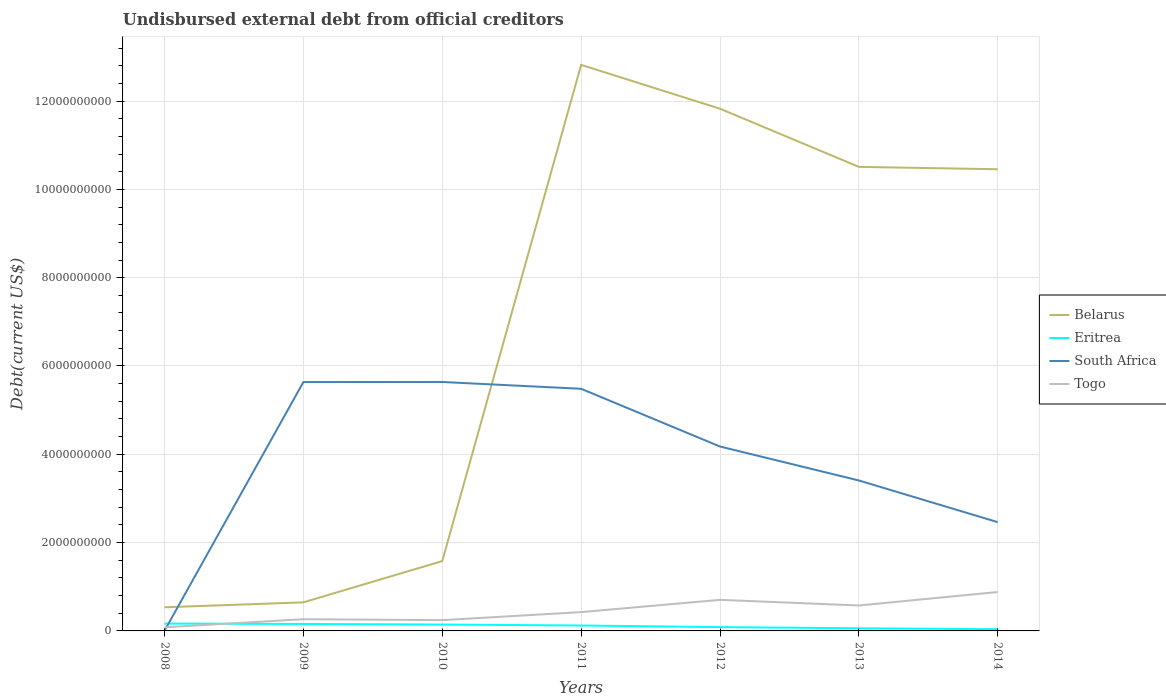Is the number of lines equal to the number of legend labels?
Your answer should be very brief. Yes. Across all years, what is the maximum total debt in South Africa?
Keep it short and to the point. 3.94e+06. In which year was the total debt in South Africa maximum?
Your answer should be very brief. 2008. What is the total total debt in Belarus in the graph?
Your answer should be compact. 2.36e+09. What is the difference between the highest and the second highest total debt in Togo?
Offer a very short reply. 7.99e+08. What is the difference between the highest and the lowest total debt in South Africa?
Make the answer very short. 4. How many lines are there?
Your answer should be compact. 4. What is the difference between two consecutive major ticks on the Y-axis?
Offer a very short reply. 2.00e+09. Are the values on the major ticks of Y-axis written in scientific E-notation?
Your response must be concise. No. Does the graph contain grids?
Give a very brief answer. Yes. Where does the legend appear in the graph?
Give a very brief answer. Center right. How are the legend labels stacked?
Offer a very short reply. Vertical. What is the title of the graph?
Your answer should be very brief. Undisbursed external debt from official creditors. What is the label or title of the X-axis?
Provide a short and direct response. Years. What is the label or title of the Y-axis?
Offer a very short reply. Debt(current US$). What is the Debt(current US$) in Belarus in 2008?
Make the answer very short. 5.35e+08. What is the Debt(current US$) of Eritrea in 2008?
Provide a succinct answer. 1.66e+08. What is the Debt(current US$) of South Africa in 2008?
Your answer should be very brief. 3.94e+06. What is the Debt(current US$) in Togo in 2008?
Provide a short and direct response. 8.21e+07. What is the Debt(current US$) in Belarus in 2009?
Your response must be concise. 6.47e+08. What is the Debt(current US$) of Eritrea in 2009?
Provide a succinct answer. 1.58e+08. What is the Debt(current US$) in South Africa in 2009?
Your answer should be compact. 5.64e+09. What is the Debt(current US$) of Togo in 2009?
Provide a succinct answer. 2.65e+08. What is the Debt(current US$) of Belarus in 2010?
Your answer should be compact. 1.58e+09. What is the Debt(current US$) in Eritrea in 2010?
Ensure brevity in your answer.  1.45e+08. What is the Debt(current US$) of South Africa in 2010?
Your answer should be compact. 5.64e+09. What is the Debt(current US$) of Togo in 2010?
Give a very brief answer. 2.44e+08. What is the Debt(current US$) in Belarus in 2011?
Make the answer very short. 1.28e+1. What is the Debt(current US$) of Eritrea in 2011?
Provide a succinct answer. 1.23e+08. What is the Debt(current US$) in South Africa in 2011?
Your answer should be very brief. 5.48e+09. What is the Debt(current US$) of Togo in 2011?
Provide a succinct answer. 4.26e+08. What is the Debt(current US$) of Belarus in 2012?
Your answer should be very brief. 1.18e+1. What is the Debt(current US$) of Eritrea in 2012?
Your answer should be very brief. 8.58e+07. What is the Debt(current US$) of South Africa in 2012?
Your response must be concise. 4.18e+09. What is the Debt(current US$) in Togo in 2012?
Give a very brief answer. 7.04e+08. What is the Debt(current US$) of Belarus in 2013?
Offer a terse response. 1.05e+1. What is the Debt(current US$) in Eritrea in 2013?
Your answer should be compact. 5.98e+07. What is the Debt(current US$) of South Africa in 2013?
Offer a very short reply. 3.41e+09. What is the Debt(current US$) in Togo in 2013?
Make the answer very short. 5.76e+08. What is the Debt(current US$) in Belarus in 2014?
Provide a short and direct response. 1.05e+1. What is the Debt(current US$) of Eritrea in 2014?
Ensure brevity in your answer.  3.90e+07. What is the Debt(current US$) in South Africa in 2014?
Your answer should be very brief. 2.46e+09. What is the Debt(current US$) of Togo in 2014?
Your response must be concise. 8.81e+08. Across all years, what is the maximum Debt(current US$) in Belarus?
Offer a very short reply. 1.28e+1. Across all years, what is the maximum Debt(current US$) in Eritrea?
Your answer should be compact. 1.66e+08. Across all years, what is the maximum Debt(current US$) in South Africa?
Provide a succinct answer. 5.64e+09. Across all years, what is the maximum Debt(current US$) in Togo?
Your answer should be compact. 8.81e+08. Across all years, what is the minimum Debt(current US$) in Belarus?
Your response must be concise. 5.35e+08. Across all years, what is the minimum Debt(current US$) in Eritrea?
Offer a terse response. 3.90e+07. Across all years, what is the minimum Debt(current US$) in South Africa?
Keep it short and to the point. 3.94e+06. Across all years, what is the minimum Debt(current US$) in Togo?
Your answer should be compact. 8.21e+07. What is the total Debt(current US$) in Belarus in the graph?
Make the answer very short. 4.84e+1. What is the total Debt(current US$) in Eritrea in the graph?
Keep it short and to the point. 7.76e+08. What is the total Debt(current US$) in South Africa in the graph?
Provide a short and direct response. 2.68e+1. What is the total Debt(current US$) of Togo in the graph?
Offer a very short reply. 3.18e+09. What is the difference between the Debt(current US$) of Belarus in 2008 and that in 2009?
Make the answer very short. -1.12e+08. What is the difference between the Debt(current US$) in Eritrea in 2008 and that in 2009?
Make the answer very short. 8.26e+06. What is the difference between the Debt(current US$) in South Africa in 2008 and that in 2009?
Keep it short and to the point. -5.63e+09. What is the difference between the Debt(current US$) of Togo in 2008 and that in 2009?
Offer a terse response. -1.83e+08. What is the difference between the Debt(current US$) of Belarus in 2008 and that in 2010?
Your response must be concise. -1.05e+09. What is the difference between the Debt(current US$) in Eritrea in 2008 and that in 2010?
Provide a succinct answer. 2.12e+07. What is the difference between the Debt(current US$) of South Africa in 2008 and that in 2010?
Your response must be concise. -5.63e+09. What is the difference between the Debt(current US$) in Togo in 2008 and that in 2010?
Provide a short and direct response. -1.62e+08. What is the difference between the Debt(current US$) of Belarus in 2008 and that in 2011?
Your response must be concise. -1.23e+1. What is the difference between the Debt(current US$) of Eritrea in 2008 and that in 2011?
Offer a very short reply. 4.30e+07. What is the difference between the Debt(current US$) in South Africa in 2008 and that in 2011?
Give a very brief answer. -5.48e+09. What is the difference between the Debt(current US$) of Togo in 2008 and that in 2011?
Ensure brevity in your answer.  -3.44e+08. What is the difference between the Debt(current US$) in Belarus in 2008 and that in 2012?
Keep it short and to the point. -1.13e+1. What is the difference between the Debt(current US$) in Eritrea in 2008 and that in 2012?
Offer a terse response. 8.01e+07. What is the difference between the Debt(current US$) in South Africa in 2008 and that in 2012?
Keep it short and to the point. -4.17e+09. What is the difference between the Debt(current US$) in Togo in 2008 and that in 2012?
Your answer should be very brief. -6.22e+08. What is the difference between the Debt(current US$) of Belarus in 2008 and that in 2013?
Keep it short and to the point. -9.97e+09. What is the difference between the Debt(current US$) of Eritrea in 2008 and that in 2013?
Give a very brief answer. 1.06e+08. What is the difference between the Debt(current US$) of South Africa in 2008 and that in 2013?
Keep it short and to the point. -3.40e+09. What is the difference between the Debt(current US$) in Togo in 2008 and that in 2013?
Your answer should be compact. -4.94e+08. What is the difference between the Debt(current US$) of Belarus in 2008 and that in 2014?
Provide a short and direct response. -9.92e+09. What is the difference between the Debt(current US$) in Eritrea in 2008 and that in 2014?
Your response must be concise. 1.27e+08. What is the difference between the Debt(current US$) in South Africa in 2008 and that in 2014?
Your answer should be compact. -2.46e+09. What is the difference between the Debt(current US$) in Togo in 2008 and that in 2014?
Your answer should be compact. -7.99e+08. What is the difference between the Debt(current US$) in Belarus in 2009 and that in 2010?
Provide a succinct answer. -9.34e+08. What is the difference between the Debt(current US$) of Eritrea in 2009 and that in 2010?
Give a very brief answer. 1.29e+07. What is the difference between the Debt(current US$) of South Africa in 2009 and that in 2010?
Provide a succinct answer. -1.40e+06. What is the difference between the Debt(current US$) of Togo in 2009 and that in 2010?
Provide a short and direct response. 2.11e+07. What is the difference between the Debt(current US$) of Belarus in 2009 and that in 2011?
Your answer should be very brief. -1.22e+1. What is the difference between the Debt(current US$) in Eritrea in 2009 and that in 2011?
Make the answer very short. 3.47e+07. What is the difference between the Debt(current US$) in South Africa in 2009 and that in 2011?
Keep it short and to the point. 1.53e+08. What is the difference between the Debt(current US$) in Togo in 2009 and that in 2011?
Your answer should be compact. -1.61e+08. What is the difference between the Debt(current US$) of Belarus in 2009 and that in 2012?
Ensure brevity in your answer.  -1.12e+1. What is the difference between the Debt(current US$) of Eritrea in 2009 and that in 2012?
Offer a very short reply. 7.18e+07. What is the difference between the Debt(current US$) in South Africa in 2009 and that in 2012?
Keep it short and to the point. 1.46e+09. What is the difference between the Debt(current US$) of Togo in 2009 and that in 2012?
Ensure brevity in your answer.  -4.38e+08. What is the difference between the Debt(current US$) of Belarus in 2009 and that in 2013?
Your answer should be compact. -9.86e+09. What is the difference between the Debt(current US$) of Eritrea in 2009 and that in 2013?
Your response must be concise. 9.78e+07. What is the difference between the Debt(current US$) in South Africa in 2009 and that in 2013?
Provide a short and direct response. 2.23e+09. What is the difference between the Debt(current US$) in Togo in 2009 and that in 2013?
Make the answer very short. -3.11e+08. What is the difference between the Debt(current US$) in Belarus in 2009 and that in 2014?
Offer a very short reply. -9.81e+09. What is the difference between the Debt(current US$) in Eritrea in 2009 and that in 2014?
Your answer should be very brief. 1.19e+08. What is the difference between the Debt(current US$) in South Africa in 2009 and that in 2014?
Offer a very short reply. 3.17e+09. What is the difference between the Debt(current US$) in Togo in 2009 and that in 2014?
Provide a short and direct response. -6.16e+08. What is the difference between the Debt(current US$) of Belarus in 2010 and that in 2011?
Make the answer very short. -1.12e+1. What is the difference between the Debt(current US$) in Eritrea in 2010 and that in 2011?
Provide a succinct answer. 2.18e+07. What is the difference between the Debt(current US$) in South Africa in 2010 and that in 2011?
Your response must be concise. 1.54e+08. What is the difference between the Debt(current US$) of Togo in 2010 and that in 2011?
Make the answer very short. -1.82e+08. What is the difference between the Debt(current US$) in Belarus in 2010 and that in 2012?
Give a very brief answer. -1.02e+1. What is the difference between the Debt(current US$) of Eritrea in 2010 and that in 2012?
Give a very brief answer. 5.89e+07. What is the difference between the Debt(current US$) of South Africa in 2010 and that in 2012?
Make the answer very short. 1.46e+09. What is the difference between the Debt(current US$) of Togo in 2010 and that in 2012?
Offer a very short reply. -4.60e+08. What is the difference between the Debt(current US$) of Belarus in 2010 and that in 2013?
Give a very brief answer. -8.93e+09. What is the difference between the Debt(current US$) in Eritrea in 2010 and that in 2013?
Provide a succinct answer. 8.49e+07. What is the difference between the Debt(current US$) of South Africa in 2010 and that in 2013?
Offer a terse response. 2.23e+09. What is the difference between the Debt(current US$) of Togo in 2010 and that in 2013?
Ensure brevity in your answer.  -3.32e+08. What is the difference between the Debt(current US$) in Belarus in 2010 and that in 2014?
Keep it short and to the point. -8.87e+09. What is the difference between the Debt(current US$) in Eritrea in 2010 and that in 2014?
Provide a short and direct response. 1.06e+08. What is the difference between the Debt(current US$) of South Africa in 2010 and that in 2014?
Keep it short and to the point. 3.17e+09. What is the difference between the Debt(current US$) of Togo in 2010 and that in 2014?
Provide a succinct answer. -6.37e+08. What is the difference between the Debt(current US$) of Belarus in 2011 and that in 2012?
Your response must be concise. 9.93e+08. What is the difference between the Debt(current US$) in Eritrea in 2011 and that in 2012?
Offer a terse response. 3.71e+07. What is the difference between the Debt(current US$) of South Africa in 2011 and that in 2012?
Ensure brevity in your answer.  1.31e+09. What is the difference between the Debt(current US$) of Togo in 2011 and that in 2012?
Offer a terse response. -2.78e+08. What is the difference between the Debt(current US$) of Belarus in 2011 and that in 2013?
Ensure brevity in your answer.  2.31e+09. What is the difference between the Debt(current US$) of Eritrea in 2011 and that in 2013?
Keep it short and to the point. 6.31e+07. What is the difference between the Debt(current US$) in South Africa in 2011 and that in 2013?
Ensure brevity in your answer.  2.08e+09. What is the difference between the Debt(current US$) of Togo in 2011 and that in 2013?
Your response must be concise. -1.50e+08. What is the difference between the Debt(current US$) in Belarus in 2011 and that in 2014?
Make the answer very short. 2.36e+09. What is the difference between the Debt(current US$) of Eritrea in 2011 and that in 2014?
Make the answer very short. 8.38e+07. What is the difference between the Debt(current US$) of South Africa in 2011 and that in 2014?
Your response must be concise. 3.02e+09. What is the difference between the Debt(current US$) in Togo in 2011 and that in 2014?
Provide a short and direct response. -4.55e+08. What is the difference between the Debt(current US$) of Belarus in 2012 and that in 2013?
Provide a short and direct response. 1.32e+09. What is the difference between the Debt(current US$) of Eritrea in 2012 and that in 2013?
Make the answer very short. 2.60e+07. What is the difference between the Debt(current US$) of South Africa in 2012 and that in 2013?
Give a very brief answer. 7.69e+08. What is the difference between the Debt(current US$) of Togo in 2012 and that in 2013?
Provide a succinct answer. 1.28e+08. What is the difference between the Debt(current US$) of Belarus in 2012 and that in 2014?
Ensure brevity in your answer.  1.37e+09. What is the difference between the Debt(current US$) in Eritrea in 2012 and that in 2014?
Give a very brief answer. 4.68e+07. What is the difference between the Debt(current US$) in South Africa in 2012 and that in 2014?
Give a very brief answer. 1.71e+09. What is the difference between the Debt(current US$) in Togo in 2012 and that in 2014?
Offer a terse response. -1.77e+08. What is the difference between the Debt(current US$) of Belarus in 2013 and that in 2014?
Make the answer very short. 5.39e+07. What is the difference between the Debt(current US$) of Eritrea in 2013 and that in 2014?
Your answer should be very brief. 2.08e+07. What is the difference between the Debt(current US$) in South Africa in 2013 and that in 2014?
Offer a very short reply. 9.44e+08. What is the difference between the Debt(current US$) of Togo in 2013 and that in 2014?
Offer a terse response. -3.05e+08. What is the difference between the Debt(current US$) in Belarus in 2008 and the Debt(current US$) in Eritrea in 2009?
Your response must be concise. 3.78e+08. What is the difference between the Debt(current US$) of Belarus in 2008 and the Debt(current US$) of South Africa in 2009?
Give a very brief answer. -5.10e+09. What is the difference between the Debt(current US$) in Belarus in 2008 and the Debt(current US$) in Togo in 2009?
Your answer should be very brief. 2.70e+08. What is the difference between the Debt(current US$) in Eritrea in 2008 and the Debt(current US$) in South Africa in 2009?
Your response must be concise. -5.47e+09. What is the difference between the Debt(current US$) in Eritrea in 2008 and the Debt(current US$) in Togo in 2009?
Give a very brief answer. -9.93e+07. What is the difference between the Debt(current US$) of South Africa in 2008 and the Debt(current US$) of Togo in 2009?
Your response must be concise. -2.61e+08. What is the difference between the Debt(current US$) in Belarus in 2008 and the Debt(current US$) in Eritrea in 2010?
Your answer should be compact. 3.91e+08. What is the difference between the Debt(current US$) in Belarus in 2008 and the Debt(current US$) in South Africa in 2010?
Offer a terse response. -5.10e+09. What is the difference between the Debt(current US$) in Belarus in 2008 and the Debt(current US$) in Togo in 2010?
Give a very brief answer. 2.91e+08. What is the difference between the Debt(current US$) in Eritrea in 2008 and the Debt(current US$) in South Africa in 2010?
Your answer should be very brief. -5.47e+09. What is the difference between the Debt(current US$) of Eritrea in 2008 and the Debt(current US$) of Togo in 2010?
Offer a very short reply. -7.82e+07. What is the difference between the Debt(current US$) in South Africa in 2008 and the Debt(current US$) in Togo in 2010?
Provide a short and direct response. -2.40e+08. What is the difference between the Debt(current US$) of Belarus in 2008 and the Debt(current US$) of Eritrea in 2011?
Make the answer very short. 4.12e+08. What is the difference between the Debt(current US$) of Belarus in 2008 and the Debt(current US$) of South Africa in 2011?
Your answer should be compact. -4.95e+09. What is the difference between the Debt(current US$) in Belarus in 2008 and the Debt(current US$) in Togo in 2011?
Your response must be concise. 1.09e+08. What is the difference between the Debt(current US$) in Eritrea in 2008 and the Debt(current US$) in South Africa in 2011?
Offer a very short reply. -5.32e+09. What is the difference between the Debt(current US$) in Eritrea in 2008 and the Debt(current US$) in Togo in 2011?
Make the answer very short. -2.60e+08. What is the difference between the Debt(current US$) of South Africa in 2008 and the Debt(current US$) of Togo in 2011?
Provide a short and direct response. -4.22e+08. What is the difference between the Debt(current US$) in Belarus in 2008 and the Debt(current US$) in Eritrea in 2012?
Your answer should be very brief. 4.50e+08. What is the difference between the Debt(current US$) in Belarus in 2008 and the Debt(current US$) in South Africa in 2012?
Offer a very short reply. -3.64e+09. What is the difference between the Debt(current US$) of Belarus in 2008 and the Debt(current US$) of Togo in 2012?
Give a very brief answer. -1.68e+08. What is the difference between the Debt(current US$) in Eritrea in 2008 and the Debt(current US$) in South Africa in 2012?
Provide a short and direct response. -4.01e+09. What is the difference between the Debt(current US$) in Eritrea in 2008 and the Debt(current US$) in Togo in 2012?
Offer a terse response. -5.38e+08. What is the difference between the Debt(current US$) of South Africa in 2008 and the Debt(current US$) of Togo in 2012?
Provide a succinct answer. -7.00e+08. What is the difference between the Debt(current US$) in Belarus in 2008 and the Debt(current US$) in Eritrea in 2013?
Make the answer very short. 4.75e+08. What is the difference between the Debt(current US$) in Belarus in 2008 and the Debt(current US$) in South Africa in 2013?
Provide a succinct answer. -2.87e+09. What is the difference between the Debt(current US$) of Belarus in 2008 and the Debt(current US$) of Togo in 2013?
Keep it short and to the point. -4.06e+07. What is the difference between the Debt(current US$) of Eritrea in 2008 and the Debt(current US$) of South Africa in 2013?
Ensure brevity in your answer.  -3.24e+09. What is the difference between the Debt(current US$) of Eritrea in 2008 and the Debt(current US$) of Togo in 2013?
Give a very brief answer. -4.10e+08. What is the difference between the Debt(current US$) in South Africa in 2008 and the Debt(current US$) in Togo in 2013?
Make the answer very short. -5.72e+08. What is the difference between the Debt(current US$) of Belarus in 2008 and the Debt(current US$) of Eritrea in 2014?
Your answer should be very brief. 4.96e+08. What is the difference between the Debt(current US$) of Belarus in 2008 and the Debt(current US$) of South Africa in 2014?
Keep it short and to the point. -1.93e+09. What is the difference between the Debt(current US$) of Belarus in 2008 and the Debt(current US$) of Togo in 2014?
Provide a succinct answer. -3.46e+08. What is the difference between the Debt(current US$) in Eritrea in 2008 and the Debt(current US$) in South Africa in 2014?
Make the answer very short. -2.30e+09. What is the difference between the Debt(current US$) in Eritrea in 2008 and the Debt(current US$) in Togo in 2014?
Provide a short and direct response. -7.15e+08. What is the difference between the Debt(current US$) in South Africa in 2008 and the Debt(current US$) in Togo in 2014?
Ensure brevity in your answer.  -8.77e+08. What is the difference between the Debt(current US$) in Belarus in 2009 and the Debt(current US$) in Eritrea in 2010?
Your response must be concise. 5.03e+08. What is the difference between the Debt(current US$) in Belarus in 2009 and the Debt(current US$) in South Africa in 2010?
Ensure brevity in your answer.  -4.99e+09. What is the difference between the Debt(current US$) in Belarus in 2009 and the Debt(current US$) in Togo in 2010?
Your answer should be compact. 4.03e+08. What is the difference between the Debt(current US$) in Eritrea in 2009 and the Debt(current US$) in South Africa in 2010?
Your answer should be compact. -5.48e+09. What is the difference between the Debt(current US$) of Eritrea in 2009 and the Debt(current US$) of Togo in 2010?
Give a very brief answer. -8.65e+07. What is the difference between the Debt(current US$) of South Africa in 2009 and the Debt(current US$) of Togo in 2010?
Ensure brevity in your answer.  5.39e+09. What is the difference between the Debt(current US$) in Belarus in 2009 and the Debt(current US$) in Eritrea in 2011?
Give a very brief answer. 5.24e+08. What is the difference between the Debt(current US$) in Belarus in 2009 and the Debt(current US$) in South Africa in 2011?
Provide a short and direct response. -4.84e+09. What is the difference between the Debt(current US$) of Belarus in 2009 and the Debt(current US$) of Togo in 2011?
Keep it short and to the point. 2.21e+08. What is the difference between the Debt(current US$) in Eritrea in 2009 and the Debt(current US$) in South Africa in 2011?
Ensure brevity in your answer.  -5.33e+09. What is the difference between the Debt(current US$) in Eritrea in 2009 and the Debt(current US$) in Togo in 2011?
Keep it short and to the point. -2.68e+08. What is the difference between the Debt(current US$) in South Africa in 2009 and the Debt(current US$) in Togo in 2011?
Provide a succinct answer. 5.21e+09. What is the difference between the Debt(current US$) of Belarus in 2009 and the Debt(current US$) of Eritrea in 2012?
Provide a succinct answer. 5.61e+08. What is the difference between the Debt(current US$) of Belarus in 2009 and the Debt(current US$) of South Africa in 2012?
Offer a terse response. -3.53e+09. What is the difference between the Debt(current US$) in Belarus in 2009 and the Debt(current US$) in Togo in 2012?
Your response must be concise. -5.64e+07. What is the difference between the Debt(current US$) in Eritrea in 2009 and the Debt(current US$) in South Africa in 2012?
Your response must be concise. -4.02e+09. What is the difference between the Debt(current US$) of Eritrea in 2009 and the Debt(current US$) of Togo in 2012?
Provide a short and direct response. -5.46e+08. What is the difference between the Debt(current US$) in South Africa in 2009 and the Debt(current US$) in Togo in 2012?
Offer a very short reply. 4.93e+09. What is the difference between the Debt(current US$) in Belarus in 2009 and the Debt(current US$) in Eritrea in 2013?
Provide a short and direct response. 5.87e+08. What is the difference between the Debt(current US$) in Belarus in 2009 and the Debt(current US$) in South Africa in 2013?
Ensure brevity in your answer.  -2.76e+09. What is the difference between the Debt(current US$) of Belarus in 2009 and the Debt(current US$) of Togo in 2013?
Provide a short and direct response. 7.14e+07. What is the difference between the Debt(current US$) of Eritrea in 2009 and the Debt(current US$) of South Africa in 2013?
Give a very brief answer. -3.25e+09. What is the difference between the Debt(current US$) of Eritrea in 2009 and the Debt(current US$) of Togo in 2013?
Keep it short and to the point. -4.18e+08. What is the difference between the Debt(current US$) of South Africa in 2009 and the Debt(current US$) of Togo in 2013?
Offer a terse response. 5.06e+09. What is the difference between the Debt(current US$) of Belarus in 2009 and the Debt(current US$) of Eritrea in 2014?
Offer a very short reply. 6.08e+08. What is the difference between the Debt(current US$) of Belarus in 2009 and the Debt(current US$) of South Africa in 2014?
Give a very brief answer. -1.82e+09. What is the difference between the Debt(current US$) of Belarus in 2009 and the Debt(current US$) of Togo in 2014?
Your answer should be compact. -2.34e+08. What is the difference between the Debt(current US$) in Eritrea in 2009 and the Debt(current US$) in South Africa in 2014?
Your answer should be very brief. -2.31e+09. What is the difference between the Debt(current US$) in Eritrea in 2009 and the Debt(current US$) in Togo in 2014?
Make the answer very short. -7.24e+08. What is the difference between the Debt(current US$) of South Africa in 2009 and the Debt(current US$) of Togo in 2014?
Give a very brief answer. 4.76e+09. What is the difference between the Debt(current US$) in Belarus in 2010 and the Debt(current US$) in Eritrea in 2011?
Keep it short and to the point. 1.46e+09. What is the difference between the Debt(current US$) in Belarus in 2010 and the Debt(current US$) in South Africa in 2011?
Provide a succinct answer. -3.90e+09. What is the difference between the Debt(current US$) in Belarus in 2010 and the Debt(current US$) in Togo in 2011?
Offer a terse response. 1.16e+09. What is the difference between the Debt(current US$) in Eritrea in 2010 and the Debt(current US$) in South Africa in 2011?
Ensure brevity in your answer.  -5.34e+09. What is the difference between the Debt(current US$) in Eritrea in 2010 and the Debt(current US$) in Togo in 2011?
Offer a very short reply. -2.81e+08. What is the difference between the Debt(current US$) in South Africa in 2010 and the Debt(current US$) in Togo in 2011?
Provide a short and direct response. 5.21e+09. What is the difference between the Debt(current US$) of Belarus in 2010 and the Debt(current US$) of Eritrea in 2012?
Your answer should be compact. 1.50e+09. What is the difference between the Debt(current US$) of Belarus in 2010 and the Debt(current US$) of South Africa in 2012?
Offer a very short reply. -2.59e+09. What is the difference between the Debt(current US$) of Belarus in 2010 and the Debt(current US$) of Togo in 2012?
Provide a short and direct response. 8.78e+08. What is the difference between the Debt(current US$) of Eritrea in 2010 and the Debt(current US$) of South Africa in 2012?
Your response must be concise. -4.03e+09. What is the difference between the Debt(current US$) of Eritrea in 2010 and the Debt(current US$) of Togo in 2012?
Offer a terse response. -5.59e+08. What is the difference between the Debt(current US$) in South Africa in 2010 and the Debt(current US$) in Togo in 2012?
Provide a short and direct response. 4.93e+09. What is the difference between the Debt(current US$) of Belarus in 2010 and the Debt(current US$) of Eritrea in 2013?
Provide a succinct answer. 1.52e+09. What is the difference between the Debt(current US$) of Belarus in 2010 and the Debt(current US$) of South Africa in 2013?
Make the answer very short. -1.83e+09. What is the difference between the Debt(current US$) of Belarus in 2010 and the Debt(current US$) of Togo in 2013?
Provide a short and direct response. 1.01e+09. What is the difference between the Debt(current US$) of Eritrea in 2010 and the Debt(current US$) of South Africa in 2013?
Ensure brevity in your answer.  -3.26e+09. What is the difference between the Debt(current US$) of Eritrea in 2010 and the Debt(current US$) of Togo in 2013?
Keep it short and to the point. -4.31e+08. What is the difference between the Debt(current US$) of South Africa in 2010 and the Debt(current US$) of Togo in 2013?
Provide a succinct answer. 5.06e+09. What is the difference between the Debt(current US$) of Belarus in 2010 and the Debt(current US$) of Eritrea in 2014?
Offer a very short reply. 1.54e+09. What is the difference between the Debt(current US$) of Belarus in 2010 and the Debt(current US$) of South Africa in 2014?
Make the answer very short. -8.82e+08. What is the difference between the Debt(current US$) of Belarus in 2010 and the Debt(current US$) of Togo in 2014?
Give a very brief answer. 7.00e+08. What is the difference between the Debt(current US$) in Eritrea in 2010 and the Debt(current US$) in South Africa in 2014?
Provide a succinct answer. -2.32e+09. What is the difference between the Debt(current US$) of Eritrea in 2010 and the Debt(current US$) of Togo in 2014?
Make the answer very short. -7.36e+08. What is the difference between the Debt(current US$) of South Africa in 2010 and the Debt(current US$) of Togo in 2014?
Provide a short and direct response. 4.76e+09. What is the difference between the Debt(current US$) of Belarus in 2011 and the Debt(current US$) of Eritrea in 2012?
Your response must be concise. 1.27e+1. What is the difference between the Debt(current US$) of Belarus in 2011 and the Debt(current US$) of South Africa in 2012?
Your answer should be compact. 8.64e+09. What is the difference between the Debt(current US$) in Belarus in 2011 and the Debt(current US$) in Togo in 2012?
Offer a very short reply. 1.21e+1. What is the difference between the Debt(current US$) of Eritrea in 2011 and the Debt(current US$) of South Africa in 2012?
Keep it short and to the point. -4.05e+09. What is the difference between the Debt(current US$) in Eritrea in 2011 and the Debt(current US$) in Togo in 2012?
Give a very brief answer. -5.81e+08. What is the difference between the Debt(current US$) of South Africa in 2011 and the Debt(current US$) of Togo in 2012?
Provide a short and direct response. 4.78e+09. What is the difference between the Debt(current US$) in Belarus in 2011 and the Debt(current US$) in Eritrea in 2013?
Offer a terse response. 1.28e+1. What is the difference between the Debt(current US$) in Belarus in 2011 and the Debt(current US$) in South Africa in 2013?
Provide a succinct answer. 9.41e+09. What is the difference between the Debt(current US$) in Belarus in 2011 and the Debt(current US$) in Togo in 2013?
Your answer should be very brief. 1.22e+1. What is the difference between the Debt(current US$) in Eritrea in 2011 and the Debt(current US$) in South Africa in 2013?
Your answer should be compact. -3.28e+09. What is the difference between the Debt(current US$) in Eritrea in 2011 and the Debt(current US$) in Togo in 2013?
Keep it short and to the point. -4.53e+08. What is the difference between the Debt(current US$) in South Africa in 2011 and the Debt(current US$) in Togo in 2013?
Provide a short and direct response. 4.91e+09. What is the difference between the Debt(current US$) of Belarus in 2011 and the Debt(current US$) of Eritrea in 2014?
Offer a terse response. 1.28e+1. What is the difference between the Debt(current US$) in Belarus in 2011 and the Debt(current US$) in South Africa in 2014?
Keep it short and to the point. 1.04e+1. What is the difference between the Debt(current US$) in Belarus in 2011 and the Debt(current US$) in Togo in 2014?
Keep it short and to the point. 1.19e+1. What is the difference between the Debt(current US$) in Eritrea in 2011 and the Debt(current US$) in South Africa in 2014?
Provide a short and direct response. -2.34e+09. What is the difference between the Debt(current US$) in Eritrea in 2011 and the Debt(current US$) in Togo in 2014?
Your response must be concise. -7.58e+08. What is the difference between the Debt(current US$) of South Africa in 2011 and the Debt(current US$) of Togo in 2014?
Your response must be concise. 4.60e+09. What is the difference between the Debt(current US$) in Belarus in 2012 and the Debt(current US$) in Eritrea in 2013?
Offer a terse response. 1.18e+1. What is the difference between the Debt(current US$) of Belarus in 2012 and the Debt(current US$) of South Africa in 2013?
Make the answer very short. 8.42e+09. What is the difference between the Debt(current US$) in Belarus in 2012 and the Debt(current US$) in Togo in 2013?
Keep it short and to the point. 1.13e+1. What is the difference between the Debt(current US$) of Eritrea in 2012 and the Debt(current US$) of South Africa in 2013?
Keep it short and to the point. -3.32e+09. What is the difference between the Debt(current US$) in Eritrea in 2012 and the Debt(current US$) in Togo in 2013?
Your response must be concise. -4.90e+08. What is the difference between the Debt(current US$) of South Africa in 2012 and the Debt(current US$) of Togo in 2013?
Provide a short and direct response. 3.60e+09. What is the difference between the Debt(current US$) of Belarus in 2012 and the Debt(current US$) of Eritrea in 2014?
Keep it short and to the point. 1.18e+1. What is the difference between the Debt(current US$) in Belarus in 2012 and the Debt(current US$) in South Africa in 2014?
Offer a terse response. 9.36e+09. What is the difference between the Debt(current US$) of Belarus in 2012 and the Debt(current US$) of Togo in 2014?
Your answer should be very brief. 1.09e+1. What is the difference between the Debt(current US$) of Eritrea in 2012 and the Debt(current US$) of South Africa in 2014?
Provide a succinct answer. -2.38e+09. What is the difference between the Debt(current US$) in Eritrea in 2012 and the Debt(current US$) in Togo in 2014?
Give a very brief answer. -7.95e+08. What is the difference between the Debt(current US$) in South Africa in 2012 and the Debt(current US$) in Togo in 2014?
Provide a short and direct response. 3.29e+09. What is the difference between the Debt(current US$) in Belarus in 2013 and the Debt(current US$) in Eritrea in 2014?
Give a very brief answer. 1.05e+1. What is the difference between the Debt(current US$) of Belarus in 2013 and the Debt(current US$) of South Africa in 2014?
Offer a terse response. 8.05e+09. What is the difference between the Debt(current US$) in Belarus in 2013 and the Debt(current US$) in Togo in 2014?
Make the answer very short. 9.63e+09. What is the difference between the Debt(current US$) in Eritrea in 2013 and the Debt(current US$) in South Africa in 2014?
Your answer should be very brief. -2.40e+09. What is the difference between the Debt(current US$) of Eritrea in 2013 and the Debt(current US$) of Togo in 2014?
Offer a very short reply. -8.21e+08. What is the difference between the Debt(current US$) of South Africa in 2013 and the Debt(current US$) of Togo in 2014?
Offer a terse response. 2.53e+09. What is the average Debt(current US$) of Belarus per year?
Provide a succinct answer. 6.91e+09. What is the average Debt(current US$) in Eritrea per year?
Ensure brevity in your answer.  1.11e+08. What is the average Debt(current US$) in South Africa per year?
Ensure brevity in your answer.  3.83e+09. What is the average Debt(current US$) of Togo per year?
Keep it short and to the point. 4.54e+08. In the year 2008, what is the difference between the Debt(current US$) in Belarus and Debt(current US$) in Eritrea?
Your answer should be compact. 3.69e+08. In the year 2008, what is the difference between the Debt(current US$) of Belarus and Debt(current US$) of South Africa?
Provide a short and direct response. 5.31e+08. In the year 2008, what is the difference between the Debt(current US$) of Belarus and Debt(current US$) of Togo?
Your response must be concise. 4.53e+08. In the year 2008, what is the difference between the Debt(current US$) of Eritrea and Debt(current US$) of South Africa?
Provide a succinct answer. 1.62e+08. In the year 2008, what is the difference between the Debt(current US$) in Eritrea and Debt(current US$) in Togo?
Offer a very short reply. 8.37e+07. In the year 2008, what is the difference between the Debt(current US$) of South Africa and Debt(current US$) of Togo?
Make the answer very short. -7.82e+07. In the year 2009, what is the difference between the Debt(current US$) in Belarus and Debt(current US$) in Eritrea?
Keep it short and to the point. 4.90e+08. In the year 2009, what is the difference between the Debt(current US$) of Belarus and Debt(current US$) of South Africa?
Provide a short and direct response. -4.99e+09. In the year 2009, what is the difference between the Debt(current US$) in Belarus and Debt(current US$) in Togo?
Give a very brief answer. 3.82e+08. In the year 2009, what is the difference between the Debt(current US$) of Eritrea and Debt(current US$) of South Africa?
Offer a terse response. -5.48e+09. In the year 2009, what is the difference between the Debt(current US$) in Eritrea and Debt(current US$) in Togo?
Ensure brevity in your answer.  -1.08e+08. In the year 2009, what is the difference between the Debt(current US$) in South Africa and Debt(current US$) in Togo?
Offer a terse response. 5.37e+09. In the year 2010, what is the difference between the Debt(current US$) of Belarus and Debt(current US$) of Eritrea?
Keep it short and to the point. 1.44e+09. In the year 2010, what is the difference between the Debt(current US$) in Belarus and Debt(current US$) in South Africa?
Offer a very short reply. -4.06e+09. In the year 2010, what is the difference between the Debt(current US$) in Belarus and Debt(current US$) in Togo?
Provide a short and direct response. 1.34e+09. In the year 2010, what is the difference between the Debt(current US$) in Eritrea and Debt(current US$) in South Africa?
Ensure brevity in your answer.  -5.49e+09. In the year 2010, what is the difference between the Debt(current US$) of Eritrea and Debt(current US$) of Togo?
Your answer should be compact. -9.94e+07. In the year 2010, what is the difference between the Debt(current US$) of South Africa and Debt(current US$) of Togo?
Provide a short and direct response. 5.39e+09. In the year 2011, what is the difference between the Debt(current US$) in Belarus and Debt(current US$) in Eritrea?
Offer a very short reply. 1.27e+1. In the year 2011, what is the difference between the Debt(current US$) in Belarus and Debt(current US$) in South Africa?
Offer a very short reply. 7.34e+09. In the year 2011, what is the difference between the Debt(current US$) in Belarus and Debt(current US$) in Togo?
Your answer should be compact. 1.24e+1. In the year 2011, what is the difference between the Debt(current US$) of Eritrea and Debt(current US$) of South Africa?
Make the answer very short. -5.36e+09. In the year 2011, what is the difference between the Debt(current US$) in Eritrea and Debt(current US$) in Togo?
Your answer should be very brief. -3.03e+08. In the year 2011, what is the difference between the Debt(current US$) in South Africa and Debt(current US$) in Togo?
Offer a very short reply. 5.06e+09. In the year 2012, what is the difference between the Debt(current US$) in Belarus and Debt(current US$) in Eritrea?
Provide a short and direct response. 1.17e+1. In the year 2012, what is the difference between the Debt(current US$) in Belarus and Debt(current US$) in South Africa?
Make the answer very short. 7.65e+09. In the year 2012, what is the difference between the Debt(current US$) in Belarus and Debt(current US$) in Togo?
Your response must be concise. 1.11e+1. In the year 2012, what is the difference between the Debt(current US$) in Eritrea and Debt(current US$) in South Africa?
Your answer should be compact. -4.09e+09. In the year 2012, what is the difference between the Debt(current US$) of Eritrea and Debt(current US$) of Togo?
Your response must be concise. -6.18e+08. In the year 2012, what is the difference between the Debt(current US$) in South Africa and Debt(current US$) in Togo?
Provide a succinct answer. 3.47e+09. In the year 2013, what is the difference between the Debt(current US$) of Belarus and Debt(current US$) of Eritrea?
Make the answer very short. 1.04e+1. In the year 2013, what is the difference between the Debt(current US$) in Belarus and Debt(current US$) in South Africa?
Offer a very short reply. 7.10e+09. In the year 2013, what is the difference between the Debt(current US$) of Belarus and Debt(current US$) of Togo?
Keep it short and to the point. 9.93e+09. In the year 2013, what is the difference between the Debt(current US$) of Eritrea and Debt(current US$) of South Africa?
Your answer should be very brief. -3.35e+09. In the year 2013, what is the difference between the Debt(current US$) of Eritrea and Debt(current US$) of Togo?
Give a very brief answer. -5.16e+08. In the year 2013, what is the difference between the Debt(current US$) of South Africa and Debt(current US$) of Togo?
Provide a short and direct response. 2.83e+09. In the year 2014, what is the difference between the Debt(current US$) in Belarus and Debt(current US$) in Eritrea?
Give a very brief answer. 1.04e+1. In the year 2014, what is the difference between the Debt(current US$) in Belarus and Debt(current US$) in South Africa?
Your answer should be very brief. 7.99e+09. In the year 2014, what is the difference between the Debt(current US$) of Belarus and Debt(current US$) of Togo?
Provide a short and direct response. 9.57e+09. In the year 2014, what is the difference between the Debt(current US$) of Eritrea and Debt(current US$) of South Africa?
Make the answer very short. -2.42e+09. In the year 2014, what is the difference between the Debt(current US$) of Eritrea and Debt(current US$) of Togo?
Give a very brief answer. -8.42e+08. In the year 2014, what is the difference between the Debt(current US$) in South Africa and Debt(current US$) in Togo?
Your answer should be compact. 1.58e+09. What is the ratio of the Debt(current US$) in Belarus in 2008 to that in 2009?
Ensure brevity in your answer.  0.83. What is the ratio of the Debt(current US$) of Eritrea in 2008 to that in 2009?
Offer a very short reply. 1.05. What is the ratio of the Debt(current US$) in South Africa in 2008 to that in 2009?
Offer a terse response. 0. What is the ratio of the Debt(current US$) of Togo in 2008 to that in 2009?
Ensure brevity in your answer.  0.31. What is the ratio of the Debt(current US$) in Belarus in 2008 to that in 2010?
Provide a short and direct response. 0.34. What is the ratio of the Debt(current US$) of Eritrea in 2008 to that in 2010?
Offer a terse response. 1.15. What is the ratio of the Debt(current US$) of South Africa in 2008 to that in 2010?
Offer a very short reply. 0. What is the ratio of the Debt(current US$) of Togo in 2008 to that in 2010?
Give a very brief answer. 0.34. What is the ratio of the Debt(current US$) of Belarus in 2008 to that in 2011?
Make the answer very short. 0.04. What is the ratio of the Debt(current US$) of Eritrea in 2008 to that in 2011?
Keep it short and to the point. 1.35. What is the ratio of the Debt(current US$) of South Africa in 2008 to that in 2011?
Give a very brief answer. 0. What is the ratio of the Debt(current US$) of Togo in 2008 to that in 2011?
Give a very brief answer. 0.19. What is the ratio of the Debt(current US$) of Belarus in 2008 to that in 2012?
Your answer should be very brief. 0.05. What is the ratio of the Debt(current US$) of Eritrea in 2008 to that in 2012?
Your response must be concise. 1.93. What is the ratio of the Debt(current US$) of South Africa in 2008 to that in 2012?
Your response must be concise. 0. What is the ratio of the Debt(current US$) in Togo in 2008 to that in 2012?
Ensure brevity in your answer.  0.12. What is the ratio of the Debt(current US$) in Belarus in 2008 to that in 2013?
Ensure brevity in your answer.  0.05. What is the ratio of the Debt(current US$) of Eritrea in 2008 to that in 2013?
Keep it short and to the point. 2.77. What is the ratio of the Debt(current US$) in South Africa in 2008 to that in 2013?
Make the answer very short. 0. What is the ratio of the Debt(current US$) of Togo in 2008 to that in 2013?
Provide a short and direct response. 0.14. What is the ratio of the Debt(current US$) in Belarus in 2008 to that in 2014?
Keep it short and to the point. 0.05. What is the ratio of the Debt(current US$) of Eritrea in 2008 to that in 2014?
Give a very brief answer. 4.25. What is the ratio of the Debt(current US$) of South Africa in 2008 to that in 2014?
Keep it short and to the point. 0. What is the ratio of the Debt(current US$) in Togo in 2008 to that in 2014?
Keep it short and to the point. 0.09. What is the ratio of the Debt(current US$) of Belarus in 2009 to that in 2010?
Provide a short and direct response. 0.41. What is the ratio of the Debt(current US$) in Eritrea in 2009 to that in 2010?
Offer a very short reply. 1.09. What is the ratio of the Debt(current US$) in Togo in 2009 to that in 2010?
Your answer should be compact. 1.09. What is the ratio of the Debt(current US$) in Belarus in 2009 to that in 2011?
Provide a succinct answer. 0.05. What is the ratio of the Debt(current US$) of Eritrea in 2009 to that in 2011?
Ensure brevity in your answer.  1.28. What is the ratio of the Debt(current US$) of South Africa in 2009 to that in 2011?
Make the answer very short. 1.03. What is the ratio of the Debt(current US$) in Togo in 2009 to that in 2011?
Your answer should be very brief. 0.62. What is the ratio of the Debt(current US$) of Belarus in 2009 to that in 2012?
Your response must be concise. 0.05. What is the ratio of the Debt(current US$) of Eritrea in 2009 to that in 2012?
Your answer should be very brief. 1.84. What is the ratio of the Debt(current US$) in South Africa in 2009 to that in 2012?
Give a very brief answer. 1.35. What is the ratio of the Debt(current US$) of Togo in 2009 to that in 2012?
Your answer should be very brief. 0.38. What is the ratio of the Debt(current US$) of Belarus in 2009 to that in 2013?
Keep it short and to the point. 0.06. What is the ratio of the Debt(current US$) in Eritrea in 2009 to that in 2013?
Your answer should be very brief. 2.64. What is the ratio of the Debt(current US$) of South Africa in 2009 to that in 2013?
Your answer should be compact. 1.65. What is the ratio of the Debt(current US$) in Togo in 2009 to that in 2013?
Make the answer very short. 0.46. What is the ratio of the Debt(current US$) in Belarus in 2009 to that in 2014?
Your answer should be very brief. 0.06. What is the ratio of the Debt(current US$) of Eritrea in 2009 to that in 2014?
Offer a terse response. 4.04. What is the ratio of the Debt(current US$) in South Africa in 2009 to that in 2014?
Provide a short and direct response. 2.29. What is the ratio of the Debt(current US$) in Togo in 2009 to that in 2014?
Offer a very short reply. 0.3. What is the ratio of the Debt(current US$) of Belarus in 2010 to that in 2011?
Make the answer very short. 0.12. What is the ratio of the Debt(current US$) in Eritrea in 2010 to that in 2011?
Offer a terse response. 1.18. What is the ratio of the Debt(current US$) of South Africa in 2010 to that in 2011?
Provide a short and direct response. 1.03. What is the ratio of the Debt(current US$) in Togo in 2010 to that in 2011?
Your response must be concise. 0.57. What is the ratio of the Debt(current US$) of Belarus in 2010 to that in 2012?
Keep it short and to the point. 0.13. What is the ratio of the Debt(current US$) of Eritrea in 2010 to that in 2012?
Provide a succinct answer. 1.69. What is the ratio of the Debt(current US$) of South Africa in 2010 to that in 2012?
Your answer should be very brief. 1.35. What is the ratio of the Debt(current US$) of Togo in 2010 to that in 2012?
Give a very brief answer. 0.35. What is the ratio of the Debt(current US$) in Belarus in 2010 to that in 2013?
Your answer should be compact. 0.15. What is the ratio of the Debt(current US$) in Eritrea in 2010 to that in 2013?
Your response must be concise. 2.42. What is the ratio of the Debt(current US$) of South Africa in 2010 to that in 2013?
Ensure brevity in your answer.  1.65. What is the ratio of the Debt(current US$) of Togo in 2010 to that in 2013?
Provide a succinct answer. 0.42. What is the ratio of the Debt(current US$) in Belarus in 2010 to that in 2014?
Offer a very short reply. 0.15. What is the ratio of the Debt(current US$) in Eritrea in 2010 to that in 2014?
Keep it short and to the point. 3.71. What is the ratio of the Debt(current US$) in South Africa in 2010 to that in 2014?
Keep it short and to the point. 2.29. What is the ratio of the Debt(current US$) in Togo in 2010 to that in 2014?
Your response must be concise. 0.28. What is the ratio of the Debt(current US$) in Belarus in 2011 to that in 2012?
Your response must be concise. 1.08. What is the ratio of the Debt(current US$) of Eritrea in 2011 to that in 2012?
Offer a terse response. 1.43. What is the ratio of the Debt(current US$) of South Africa in 2011 to that in 2012?
Make the answer very short. 1.31. What is the ratio of the Debt(current US$) in Togo in 2011 to that in 2012?
Your answer should be compact. 0.61. What is the ratio of the Debt(current US$) of Belarus in 2011 to that in 2013?
Keep it short and to the point. 1.22. What is the ratio of the Debt(current US$) in Eritrea in 2011 to that in 2013?
Offer a very short reply. 2.05. What is the ratio of the Debt(current US$) of South Africa in 2011 to that in 2013?
Your answer should be compact. 1.61. What is the ratio of the Debt(current US$) of Togo in 2011 to that in 2013?
Offer a very short reply. 0.74. What is the ratio of the Debt(current US$) of Belarus in 2011 to that in 2014?
Your answer should be compact. 1.23. What is the ratio of the Debt(current US$) in Eritrea in 2011 to that in 2014?
Give a very brief answer. 3.15. What is the ratio of the Debt(current US$) of South Africa in 2011 to that in 2014?
Your answer should be very brief. 2.23. What is the ratio of the Debt(current US$) in Togo in 2011 to that in 2014?
Your answer should be very brief. 0.48. What is the ratio of the Debt(current US$) of Belarus in 2012 to that in 2013?
Offer a very short reply. 1.13. What is the ratio of the Debt(current US$) in Eritrea in 2012 to that in 2013?
Provide a succinct answer. 1.43. What is the ratio of the Debt(current US$) of South Africa in 2012 to that in 2013?
Give a very brief answer. 1.23. What is the ratio of the Debt(current US$) in Togo in 2012 to that in 2013?
Your response must be concise. 1.22. What is the ratio of the Debt(current US$) of Belarus in 2012 to that in 2014?
Your answer should be very brief. 1.13. What is the ratio of the Debt(current US$) in Eritrea in 2012 to that in 2014?
Provide a short and direct response. 2.2. What is the ratio of the Debt(current US$) in South Africa in 2012 to that in 2014?
Your answer should be very brief. 1.7. What is the ratio of the Debt(current US$) of Togo in 2012 to that in 2014?
Your answer should be very brief. 0.8. What is the ratio of the Debt(current US$) in Eritrea in 2013 to that in 2014?
Provide a short and direct response. 1.53. What is the ratio of the Debt(current US$) in South Africa in 2013 to that in 2014?
Give a very brief answer. 1.38. What is the ratio of the Debt(current US$) in Togo in 2013 to that in 2014?
Offer a very short reply. 0.65. What is the difference between the highest and the second highest Debt(current US$) of Belarus?
Offer a very short reply. 9.93e+08. What is the difference between the highest and the second highest Debt(current US$) in Eritrea?
Give a very brief answer. 8.26e+06. What is the difference between the highest and the second highest Debt(current US$) of South Africa?
Provide a succinct answer. 1.40e+06. What is the difference between the highest and the second highest Debt(current US$) in Togo?
Your response must be concise. 1.77e+08. What is the difference between the highest and the lowest Debt(current US$) of Belarus?
Your answer should be compact. 1.23e+1. What is the difference between the highest and the lowest Debt(current US$) in Eritrea?
Your answer should be compact. 1.27e+08. What is the difference between the highest and the lowest Debt(current US$) in South Africa?
Offer a very short reply. 5.63e+09. What is the difference between the highest and the lowest Debt(current US$) in Togo?
Your response must be concise. 7.99e+08. 